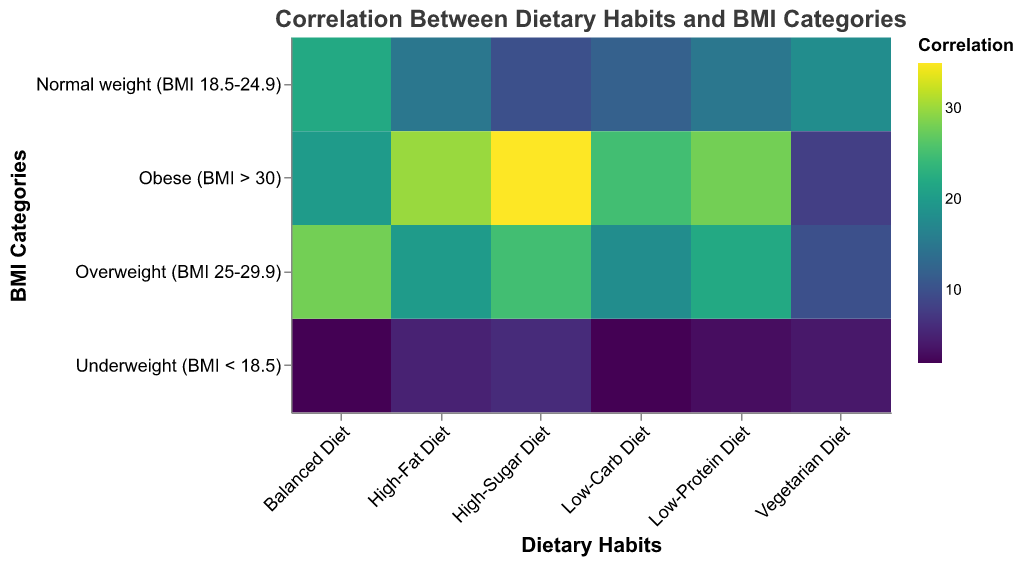What is the highest value in the "Underweight (BMI < 18.5)" category? Look at the "Underweight (BMI < 18.5)" row and identify the highest color intensity/value. The highest value is 6 in the "High-Sugar Diet" column.
Answer: 6 Which dietary habit has the lowest value for the "Obese (BMI > 30)" population? Examine the row for "Obese (BMI > 30)" and find the diet category with the lowest value, which is "Vegetarian Diet" with a value of 8.
Answer: Vegetarian Diet How does the "Balanced Diet" correlation value for "Normal weight (BMI 18.5-24.9)" compare to that of "Overweight (BMI 25-29.9)"? Compare the values in the "Balanced Diet" column for "Normal weight (BMI 18.5-24.9)" (22) and "Overweight (BMI 25-29.9)" (28). The value for "Overweight (BMI 25-29.9)" is higher.
Answer: Higher What is the sum of correlation values for the "High-Fat Diet" across all BMI categories? Add the values for "High-Fat Diet" across all categories: 5 (Underweight) + 15 (Normal weight) + 20 (Overweight) + 30 (Obese) = 70
Answer: 70 Which BMI category has the highest correlation value for a "Low-Carb Diet"? Identify the highest value in the "Low-Carb Diet" column. The "Obese (BMI > 30)" category has the highest value of 25.
Answer: Obese What is the average correlation value for "Underweight (BMI < 18.5)" across all dietary habits? Add the values for "Underweight (BMI < 18.5)" and divide by the number of categories: (5 + 2 + 6 + 4 + 3 + 2) / 6 = 22/6 ≈ 3.67
Answer: 3.67 How does the correlation value for "High-Sugar Diet" in "Overweight (BMI 25-29.9)" compare to "Obese (BMI > 30)"? Compare the two values: 25 for "Overweight (BMI 25-29.9)" and 35 for "Obese (BMI > 30)". The value is higher for the "Obese" category.
Answer: Higher Which dietary habit shows the least correlation with "Normal weight (BMI 18.5-24.9)"? Find the smallest value in the row for "Normal weight (BMI 18.5-24.9)". The "High-Sugar Diet" has the lowest value of 10.
Answer: High-Sugar Diet 